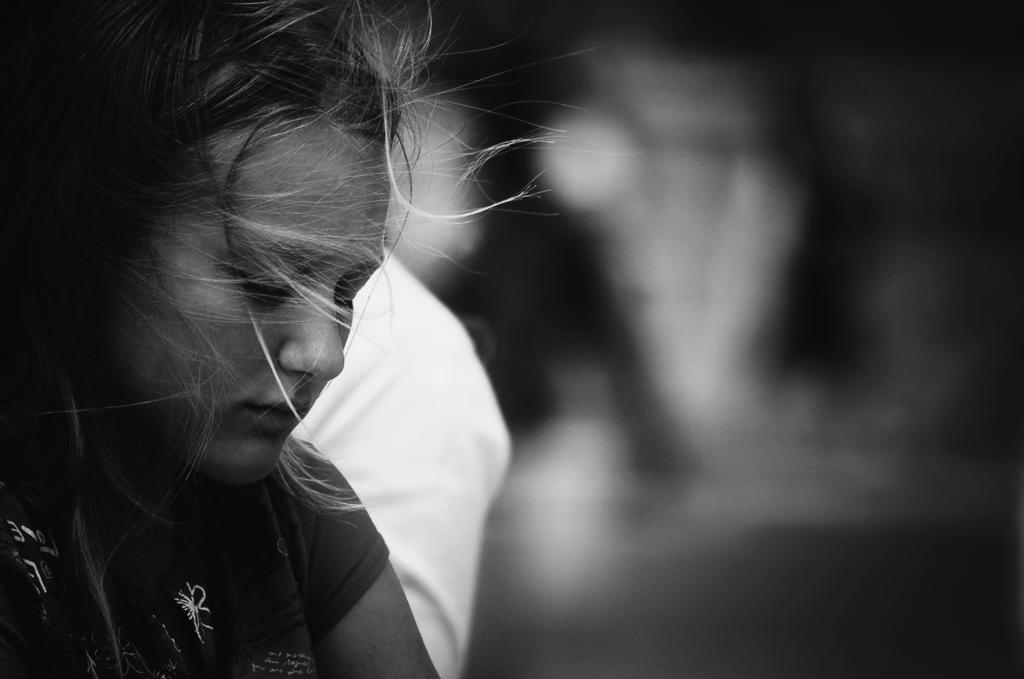What is the color scheme of the image? The image is black and white. Who or what is the main subject in the image? There is a girl in the image. What can be observed about the background of the image? The background of the image is dark. What type of waves can be seen in the image? There are no waves present in the image. Is the girl's grandfather visible in the image? There is no mention of a grandfather in the image, so it cannot be determined if he is present. 